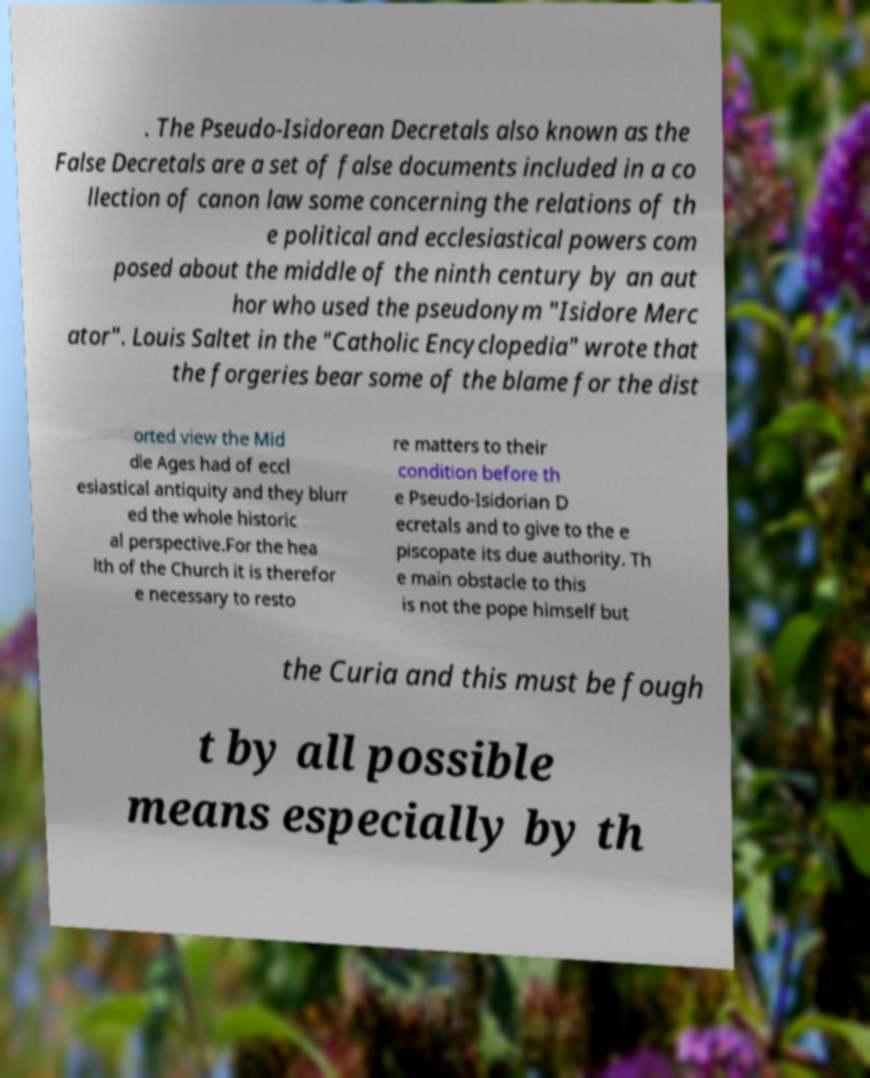What messages or text are displayed in this image? I need them in a readable, typed format. . The Pseudo-Isidorean Decretals also known as the False Decretals are a set of false documents included in a co llection of canon law some concerning the relations of th e political and ecclesiastical powers com posed about the middle of the ninth century by an aut hor who used the pseudonym "Isidore Merc ator". Louis Saltet in the "Catholic Encyclopedia" wrote that the forgeries bear some of the blame for the dist orted view the Mid dle Ages had of eccl esiastical antiquity and they blurr ed the whole historic al perspective.For the hea lth of the Church it is therefor e necessary to resto re matters to their condition before th e Pseudo-Isidorian D ecretals and to give to the e piscopate its due authority. Th e main obstacle to this is not the pope himself but the Curia and this must be fough t by all possible means especially by th 